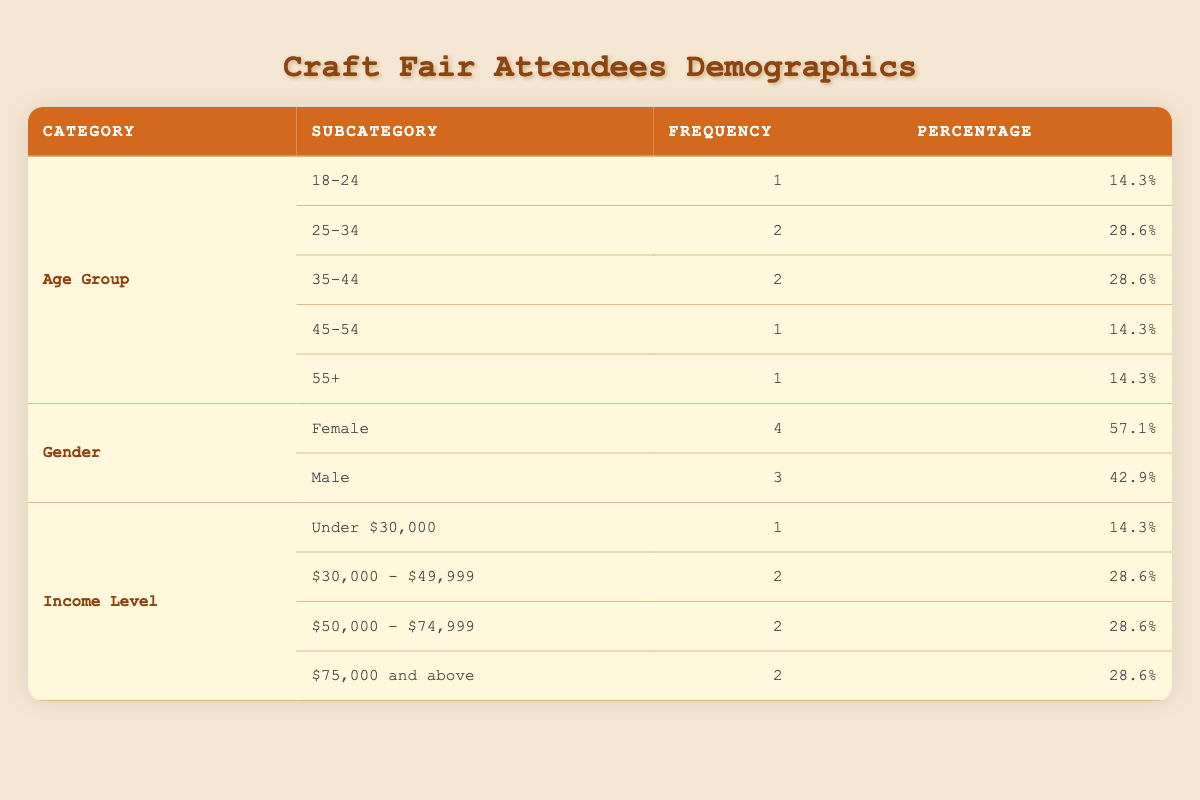What percentage of attendees are in the 18-24 age group? The frequency of attendees in the 18-24 age group is 1. The total number of attendees is 7. To find the percentage, divide 1 by 7 and multiply by 100: (1/7) * 100 ≈ 14.3%.
Answer: 14.3% How many male attendees are there compared to female attendees? There are 4 female attendees and 3 male attendees, as indicated in the table under the gender category.
Answer: 4 females, 3 males What is the combined frequency of attendees with incomes below $50,000? The frequency for "Under $30,000" is 1, and for "$30,000 - $49,999," it is 2. Summing these frequencies gives us: 1 + 2 = 3 attendees.
Answer: 3 attendees Is the majority of craft fair attendees female? The table shows 4 females and 3 males. Since 4 is greater than 3, the majority of attendees are indeed female.
Answer: Yes What age group has the same frequency as the 45-54 and 55+ age groups? The age groups 45-54 and 55+ each have a frequency of 1. Looking at the other age groups in the table, the 18-24 age group also has a frequency of 1. Therefore, they all have the same frequency.
Answer: 18-24, 45-54, 55+ What is the highest income level frequency among the attendees, and what is that frequency? The income levels "30,000 - 49,999," "$50,000 - $74,999," and "$75,000 and above" each have a frequency of 2, which is the highest in this data table since "Under $30,000" has a frequency of 1.
Answer: 2 Are there more attendees aged 35-44 than attendees with a household income of $75,000 and above? The frequency for the 35-44 age group is 2, while the income level "$75,000 and above" also has a frequency of 2. In this case, there are not more attendees in one category than the other; they are equal.
Answer: No What age groups have a frequency of 1? The age groups with a frequency of 1 are 18-24, 45-54, and 55+. This means that each of these groups has only one attendee.
Answer: 18-24, 45-54, 55+ 